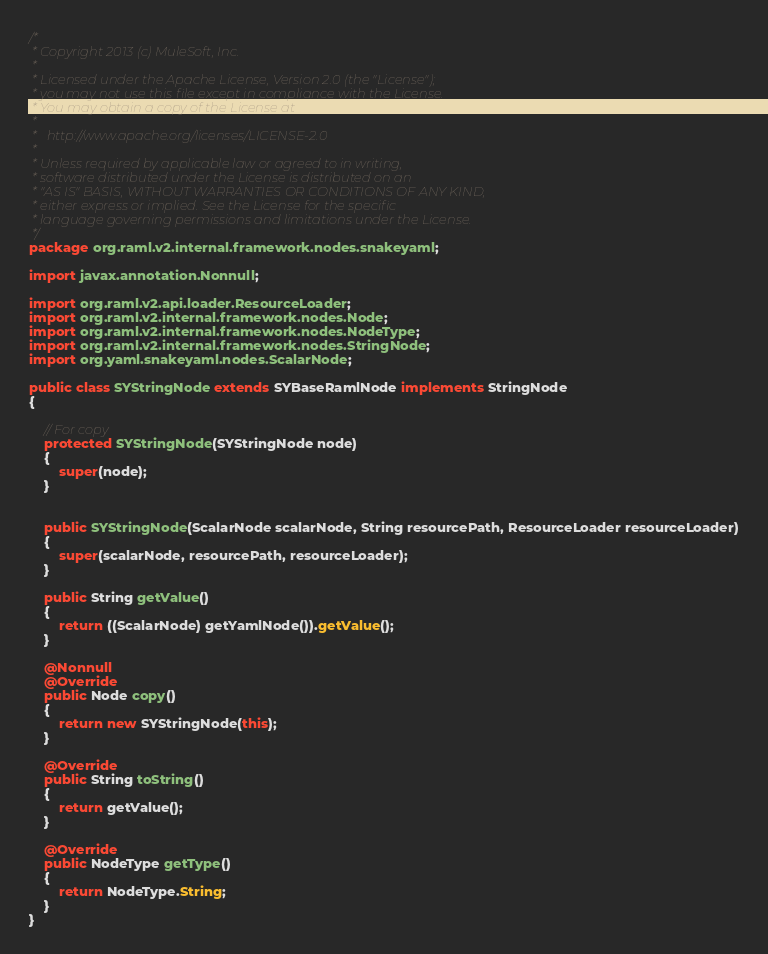Convert code to text. <code><loc_0><loc_0><loc_500><loc_500><_Java_>/*
 * Copyright 2013 (c) MuleSoft, Inc.
 *
 * Licensed under the Apache License, Version 2.0 (the "License");
 * you may not use this file except in compliance with the License.
 * You may obtain a copy of the License at
 *
 *   http://www.apache.org/licenses/LICENSE-2.0
 *
 * Unless required by applicable law or agreed to in writing,
 * software distributed under the License is distributed on an
 * "AS IS" BASIS, WITHOUT WARRANTIES OR CONDITIONS OF ANY KIND,
 * either express or implied. See the License for the specific
 * language governing permissions and limitations under the License.
 */
package org.raml.v2.internal.framework.nodes.snakeyaml;

import javax.annotation.Nonnull;

import org.raml.v2.api.loader.ResourceLoader;
import org.raml.v2.internal.framework.nodes.Node;
import org.raml.v2.internal.framework.nodes.NodeType;
import org.raml.v2.internal.framework.nodes.StringNode;
import org.yaml.snakeyaml.nodes.ScalarNode;

public class SYStringNode extends SYBaseRamlNode implements StringNode
{

    // For copy
    protected SYStringNode(SYStringNode node)
    {
        super(node);
    }


    public SYStringNode(ScalarNode scalarNode, String resourcePath, ResourceLoader resourceLoader)
    {
        super(scalarNode, resourcePath, resourceLoader);
    }

    public String getValue()
    {
        return ((ScalarNode) getYamlNode()).getValue();
    }

    @Nonnull
    @Override
    public Node copy()
    {
        return new SYStringNode(this);
    }

    @Override
    public String toString()
    {
        return getValue();
    }

    @Override
    public NodeType getType()
    {
        return NodeType.String;
    }
}
</code> 